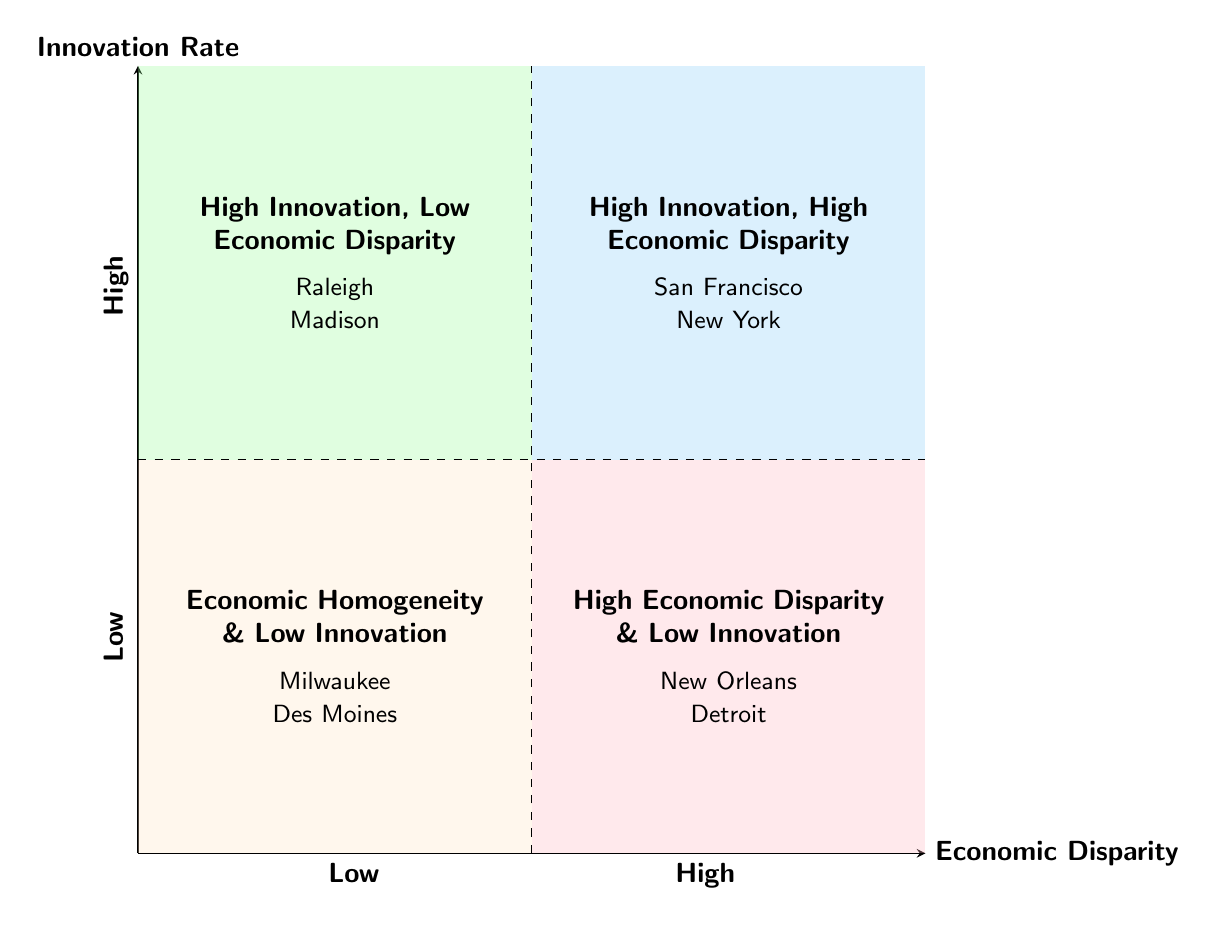What are the four quadrants in the diagram? The diagram consists of four quadrants: Economic Homogeneity & Low Innovation, High Innovation, Low Economic Disparity, High Economic Disparity & Low Innovation, and High Innovation, High Economic Disparity.
Answer: Economic Homogeneity & Low Innovation, High Innovation, Low Economic Disparity, High Economic Disparity & Low Innovation, High Innovation, High Economic Disparity Which area has the highest innovation rate? The quadrant representing areas with the highest innovation rate is "High Innovation, High Economic Disparity".
Answer: High Innovation, High Economic Disparity How many examples are given for the "High Economic Disparity & Low Innovation" quadrant? The quadrant "High Economic Disparity & Low Innovation" has two examples listed: New Orleans and Detroit. Therefore, the count is two.
Answer: 2 What is the characteristic of the "High Innovation, Low Economic Disparity" quadrant? The characteristic of this quadrant is that it includes areas with high rates of innovation and low economic disparity, meaning these areas successfully innovate without significant economic inequality.
Answer: High rates of innovation and low economic disparity Which two cities are examples of "Economic Homogeneity & Low Innovation"? The diagram lists Milwaukee and Des Moines as examples of the "Economic Homogeneity & Low Innovation" quadrant.
Answer: Milwaukee, Des Moines Which quadrant contains both innovation and economic disparity? The quadrant that contains areas with both innovation and economic disparity is "High Innovation, High Economic Disparity".
Answer: High Innovation, High Economic Disparity What colors represent the quadrants in the diagram? The quadrants are represented by the following colors: Quadrant 1 is light orange, Quadrant 2 is light green, Quadrant 3 is light pink, and Quadrant 4 is light blue.
Answer: Light orange, light green, light pink, light blue In which quadrant would you find Detroit? Detroit is found in the "High Economic Disparity & Low Innovation" quadrant, indicating it has significant economic disparity with low innovation rates.
Answer: High Economic Disparity & Low Innovation 